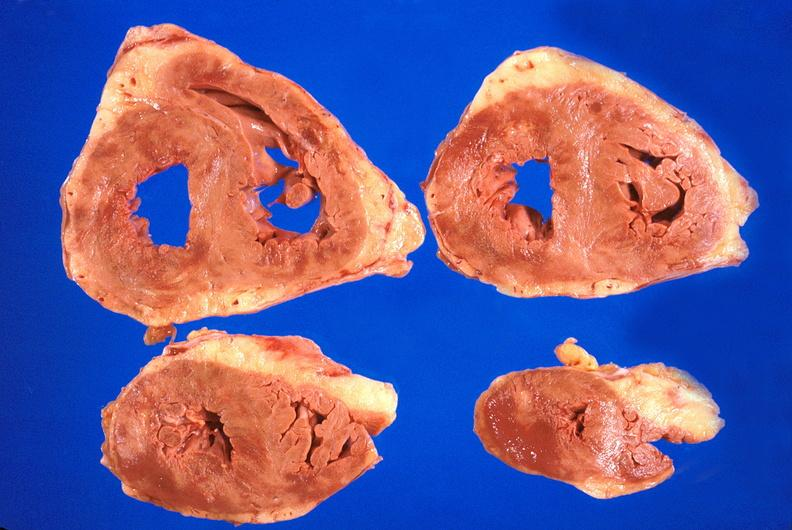what is present?
Answer the question using a single word or phrase. Cardiovascular 